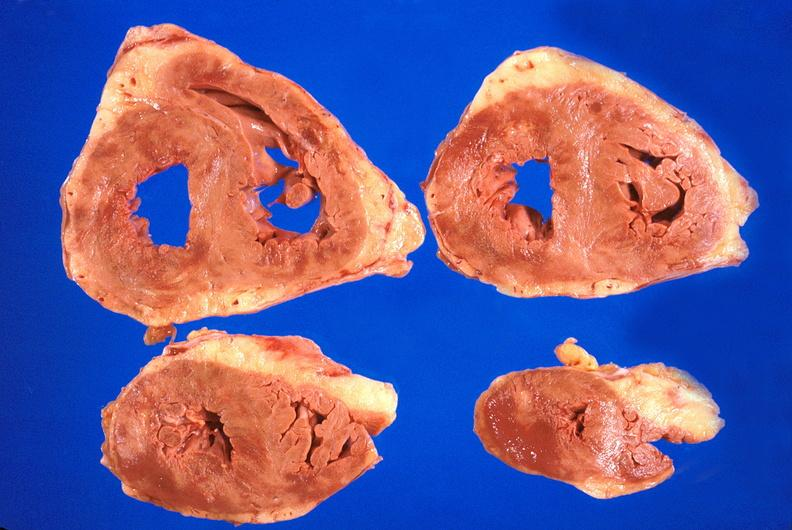what is present?
Answer the question using a single word or phrase. Cardiovascular 